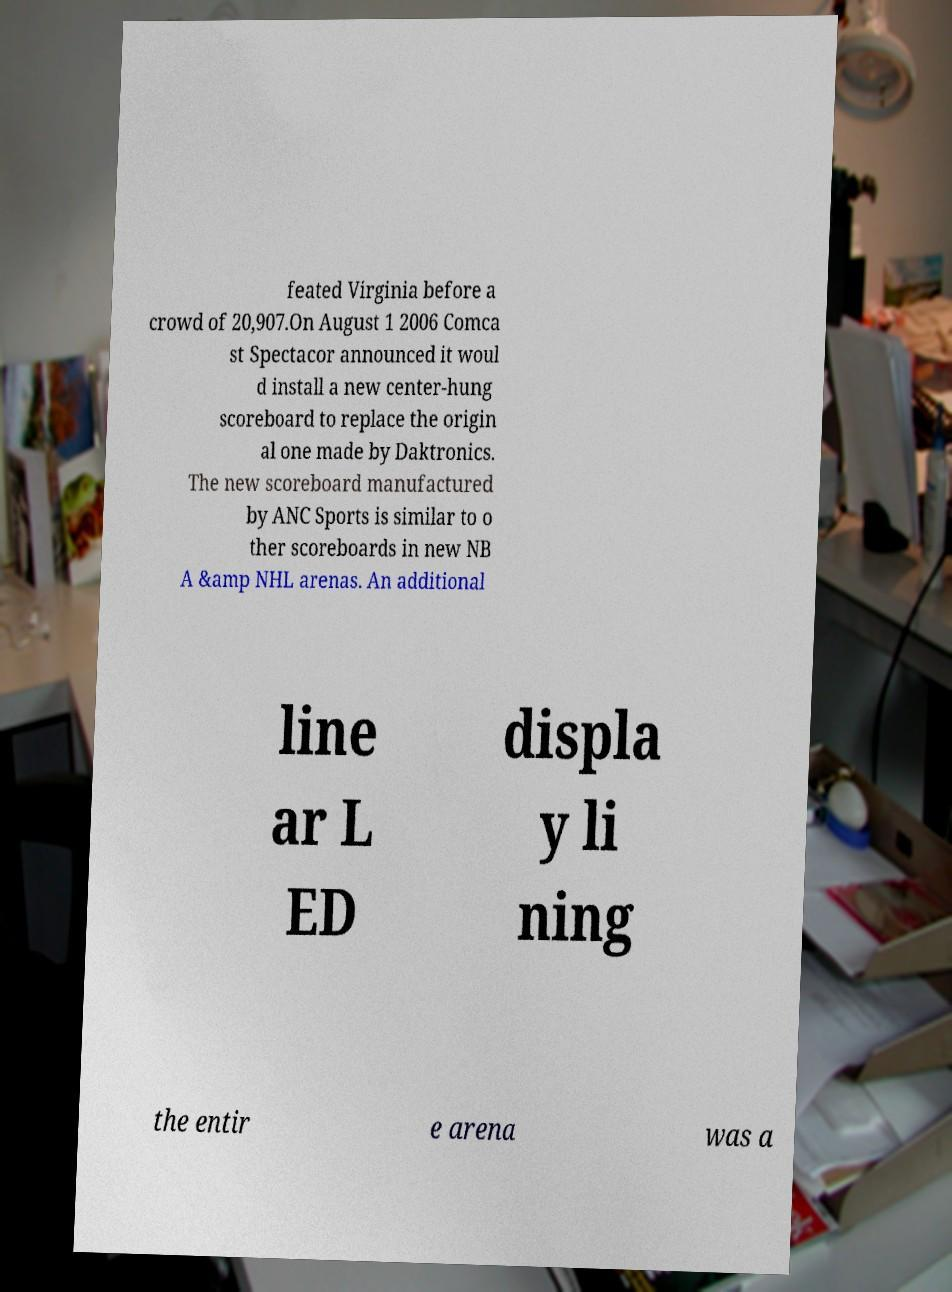Please identify and transcribe the text found in this image. feated Virginia before a crowd of 20,907.On August 1 2006 Comca st Spectacor announced it woul d install a new center-hung scoreboard to replace the origin al one made by Daktronics. The new scoreboard manufactured by ANC Sports is similar to o ther scoreboards in new NB A &amp NHL arenas. An additional line ar L ED displa y li ning the entir e arena was a 